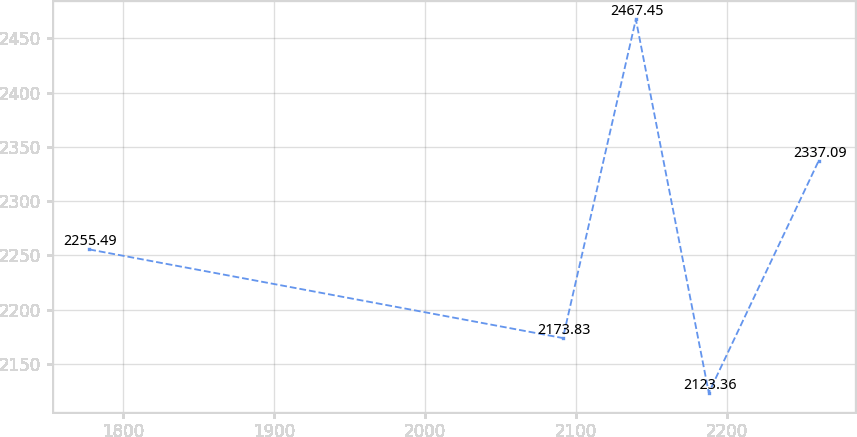Convert chart to OTSL. <chart><loc_0><loc_0><loc_500><loc_500><line_chart><ecel><fcel>Unnamed: 1<nl><fcel>1777.54<fcel>2255.49<nl><fcel>2091.19<fcel>2173.83<nl><fcel>2139.49<fcel>2467.45<nl><fcel>2187.79<fcel>2123.36<nl><fcel>2260.53<fcel>2337.09<nl></chart> 